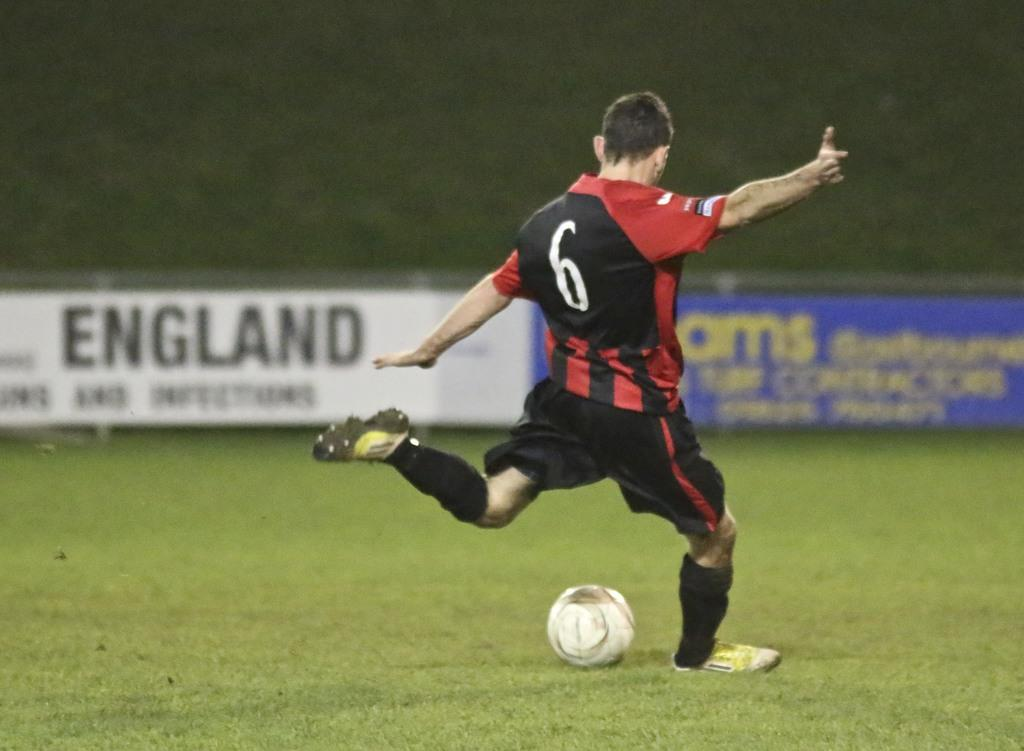Provide a one-sentence caption for the provided image. Soccer player number 6 kicks a ball on a field. 